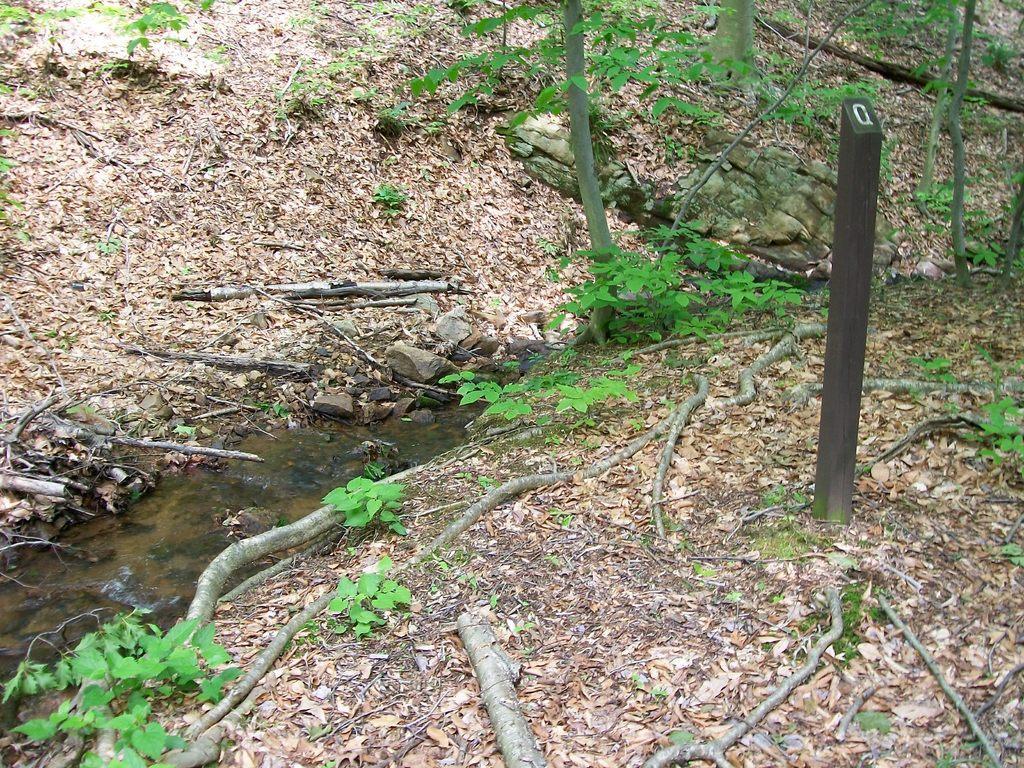Please provide a concise description of this image. Here we can see plants, wooden sticks, and water. There are dried leaves. 